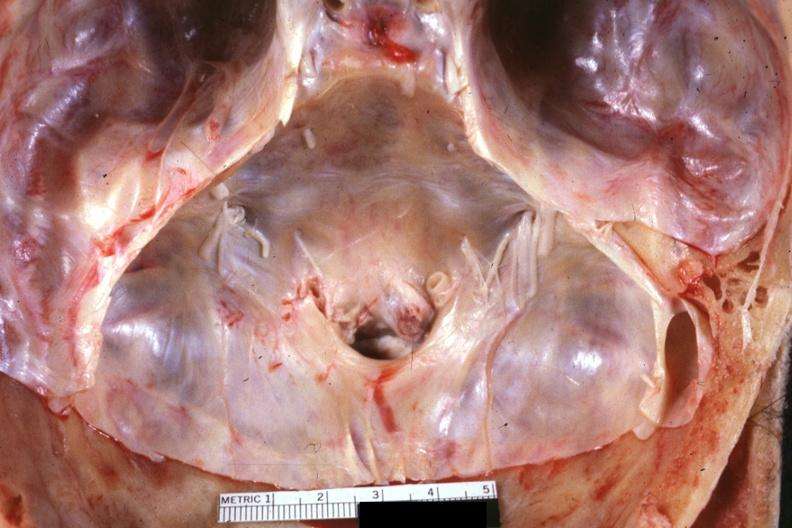s rheumatoid arthritis present?
Answer the question using a single word or phrase. Yes 